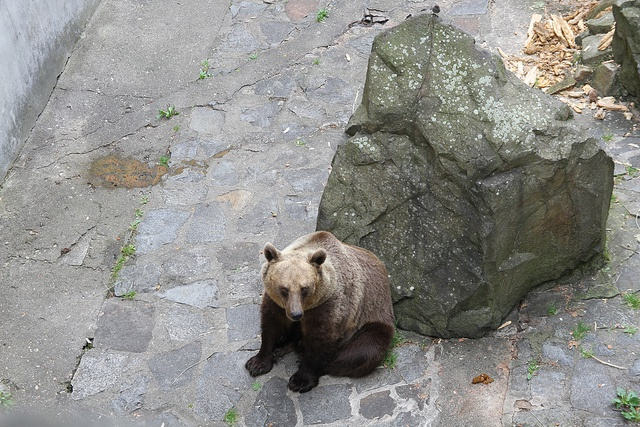Describe the objects in this image and their specific colors. I can see a bear in darkgray, black, and gray tones in this image. 